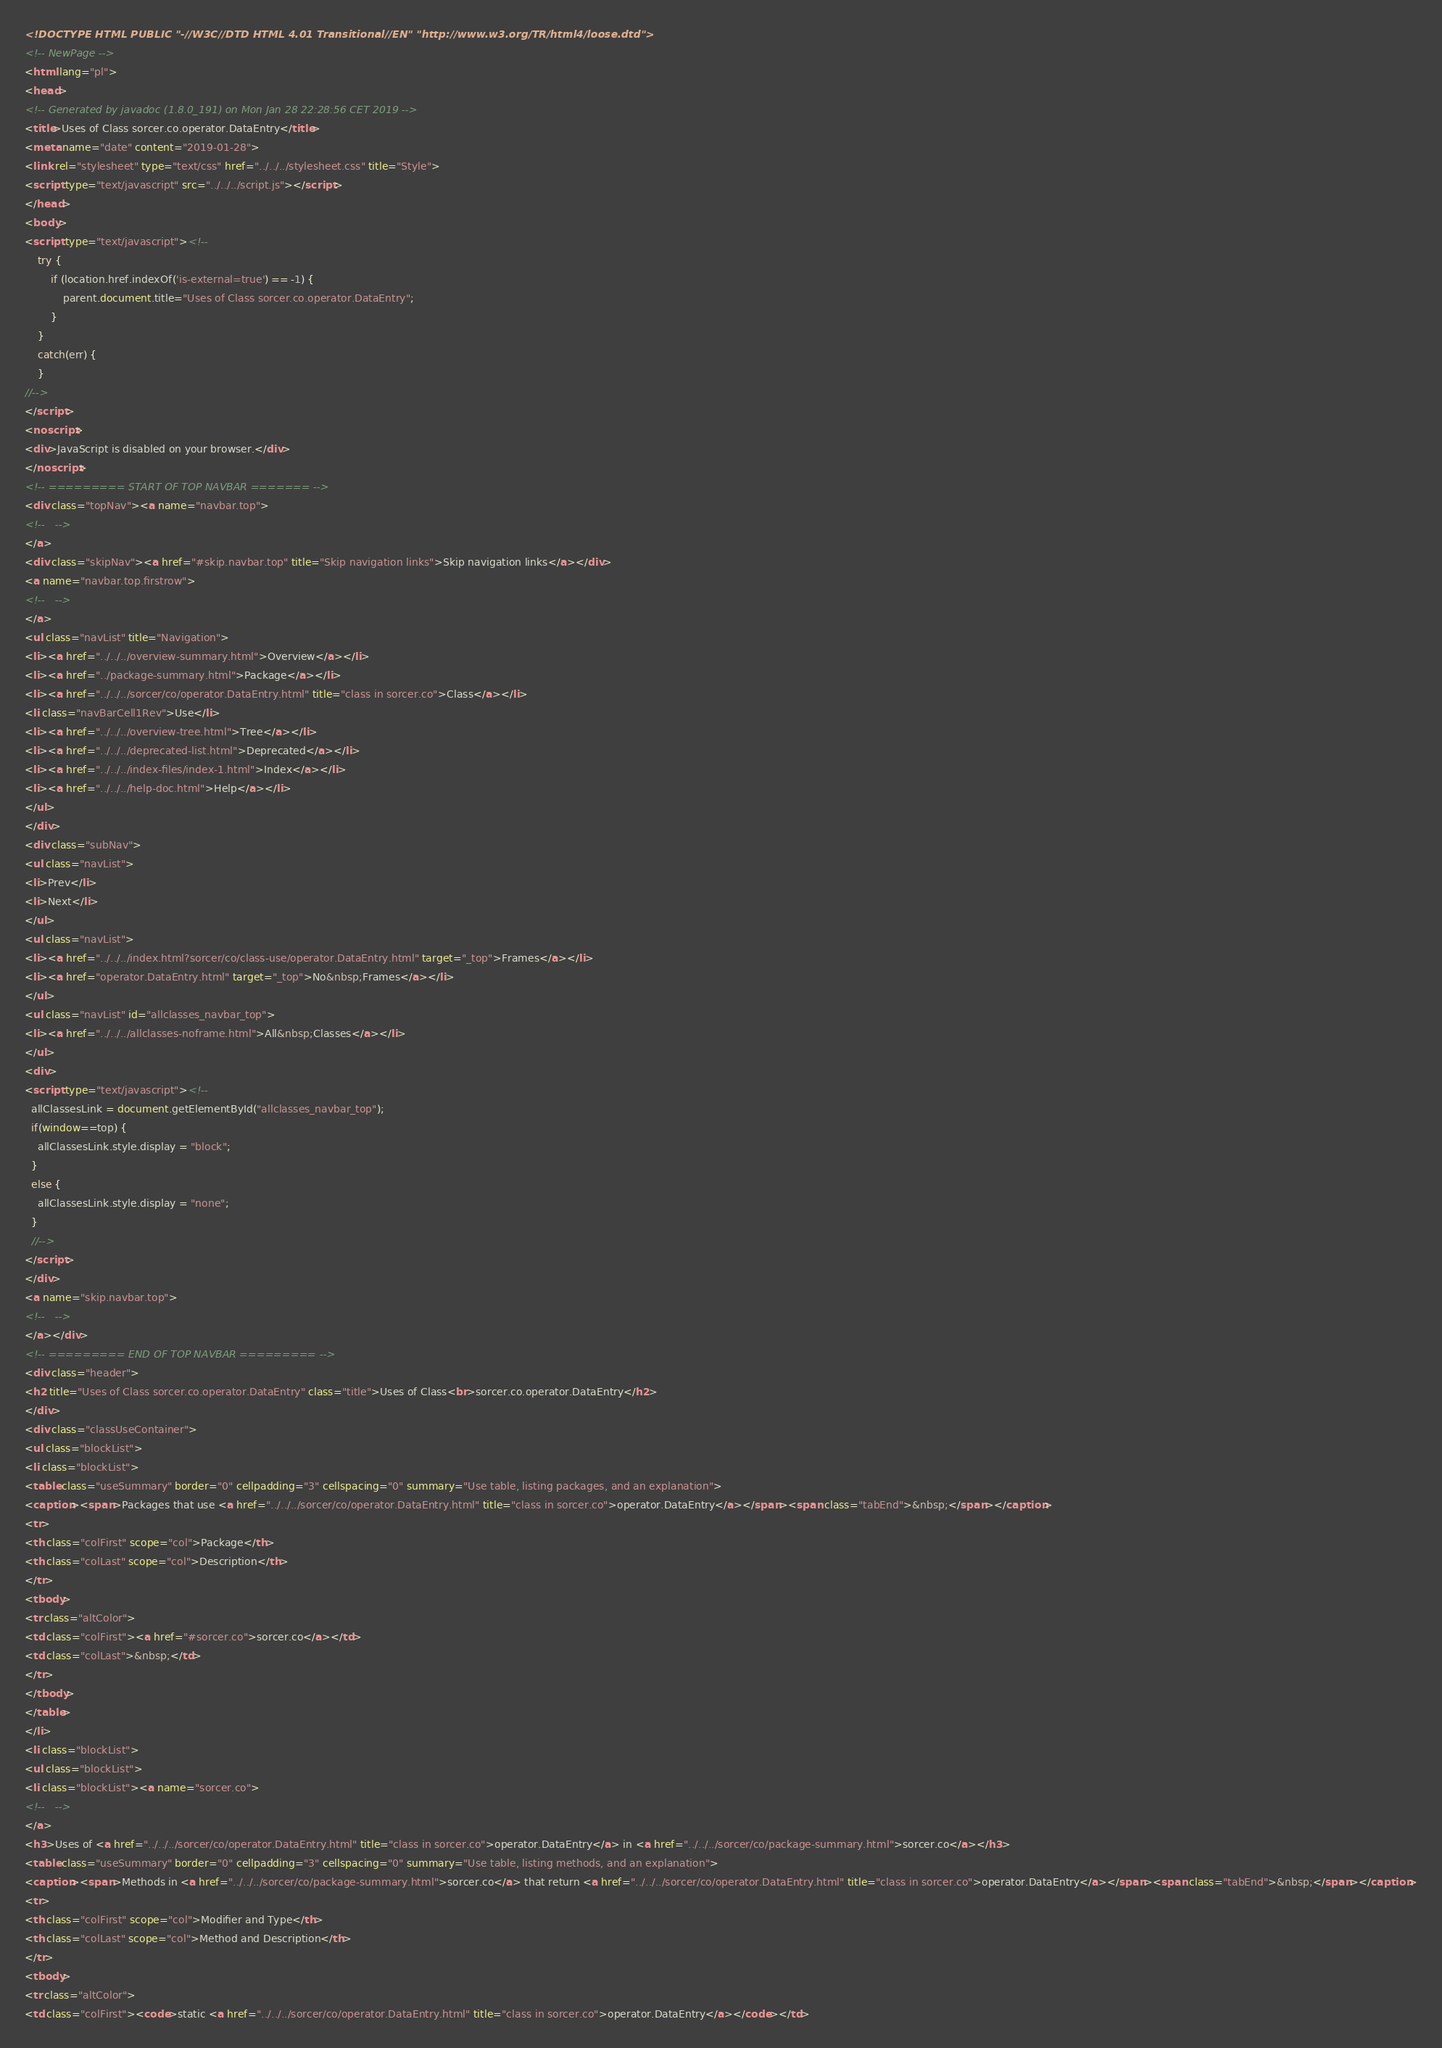Convert code to text. <code><loc_0><loc_0><loc_500><loc_500><_HTML_><!DOCTYPE HTML PUBLIC "-//W3C//DTD HTML 4.01 Transitional//EN" "http://www.w3.org/TR/html4/loose.dtd">
<!-- NewPage -->
<html lang="pl">
<head>
<!-- Generated by javadoc (1.8.0_191) on Mon Jan 28 22:28:56 CET 2019 -->
<title>Uses of Class sorcer.co.operator.DataEntry</title>
<meta name="date" content="2019-01-28">
<link rel="stylesheet" type="text/css" href="../../../stylesheet.css" title="Style">
<script type="text/javascript" src="../../../script.js"></script>
</head>
<body>
<script type="text/javascript"><!--
    try {
        if (location.href.indexOf('is-external=true') == -1) {
            parent.document.title="Uses of Class sorcer.co.operator.DataEntry";
        }
    }
    catch(err) {
    }
//-->
</script>
<noscript>
<div>JavaScript is disabled on your browser.</div>
</noscript>
<!-- ========= START OF TOP NAVBAR ======= -->
<div class="topNav"><a name="navbar.top">
<!--   -->
</a>
<div class="skipNav"><a href="#skip.navbar.top" title="Skip navigation links">Skip navigation links</a></div>
<a name="navbar.top.firstrow">
<!--   -->
</a>
<ul class="navList" title="Navigation">
<li><a href="../../../overview-summary.html">Overview</a></li>
<li><a href="../package-summary.html">Package</a></li>
<li><a href="../../../sorcer/co/operator.DataEntry.html" title="class in sorcer.co">Class</a></li>
<li class="navBarCell1Rev">Use</li>
<li><a href="../../../overview-tree.html">Tree</a></li>
<li><a href="../../../deprecated-list.html">Deprecated</a></li>
<li><a href="../../../index-files/index-1.html">Index</a></li>
<li><a href="../../../help-doc.html">Help</a></li>
</ul>
</div>
<div class="subNav">
<ul class="navList">
<li>Prev</li>
<li>Next</li>
</ul>
<ul class="navList">
<li><a href="../../../index.html?sorcer/co/class-use/operator.DataEntry.html" target="_top">Frames</a></li>
<li><a href="operator.DataEntry.html" target="_top">No&nbsp;Frames</a></li>
</ul>
<ul class="navList" id="allclasses_navbar_top">
<li><a href="../../../allclasses-noframe.html">All&nbsp;Classes</a></li>
</ul>
<div>
<script type="text/javascript"><!--
  allClassesLink = document.getElementById("allclasses_navbar_top");
  if(window==top) {
    allClassesLink.style.display = "block";
  }
  else {
    allClassesLink.style.display = "none";
  }
  //-->
</script>
</div>
<a name="skip.navbar.top">
<!--   -->
</a></div>
<!-- ========= END OF TOP NAVBAR ========= -->
<div class="header">
<h2 title="Uses of Class sorcer.co.operator.DataEntry" class="title">Uses of Class<br>sorcer.co.operator.DataEntry</h2>
</div>
<div class="classUseContainer">
<ul class="blockList">
<li class="blockList">
<table class="useSummary" border="0" cellpadding="3" cellspacing="0" summary="Use table, listing packages, and an explanation">
<caption><span>Packages that use <a href="../../../sorcer/co/operator.DataEntry.html" title="class in sorcer.co">operator.DataEntry</a></span><span class="tabEnd">&nbsp;</span></caption>
<tr>
<th class="colFirst" scope="col">Package</th>
<th class="colLast" scope="col">Description</th>
</tr>
<tbody>
<tr class="altColor">
<td class="colFirst"><a href="#sorcer.co">sorcer.co</a></td>
<td class="colLast">&nbsp;</td>
</tr>
</tbody>
</table>
</li>
<li class="blockList">
<ul class="blockList">
<li class="blockList"><a name="sorcer.co">
<!--   -->
</a>
<h3>Uses of <a href="../../../sorcer/co/operator.DataEntry.html" title="class in sorcer.co">operator.DataEntry</a> in <a href="../../../sorcer/co/package-summary.html">sorcer.co</a></h3>
<table class="useSummary" border="0" cellpadding="3" cellspacing="0" summary="Use table, listing methods, and an explanation">
<caption><span>Methods in <a href="../../../sorcer/co/package-summary.html">sorcer.co</a> that return <a href="../../../sorcer/co/operator.DataEntry.html" title="class in sorcer.co">operator.DataEntry</a></span><span class="tabEnd">&nbsp;</span></caption>
<tr>
<th class="colFirst" scope="col">Modifier and Type</th>
<th class="colLast" scope="col">Method and Description</th>
</tr>
<tbody>
<tr class="altColor">
<td class="colFirst"><code>static <a href="../../../sorcer/co/operator.DataEntry.html" title="class in sorcer.co">operator.DataEntry</a></code></td></code> 